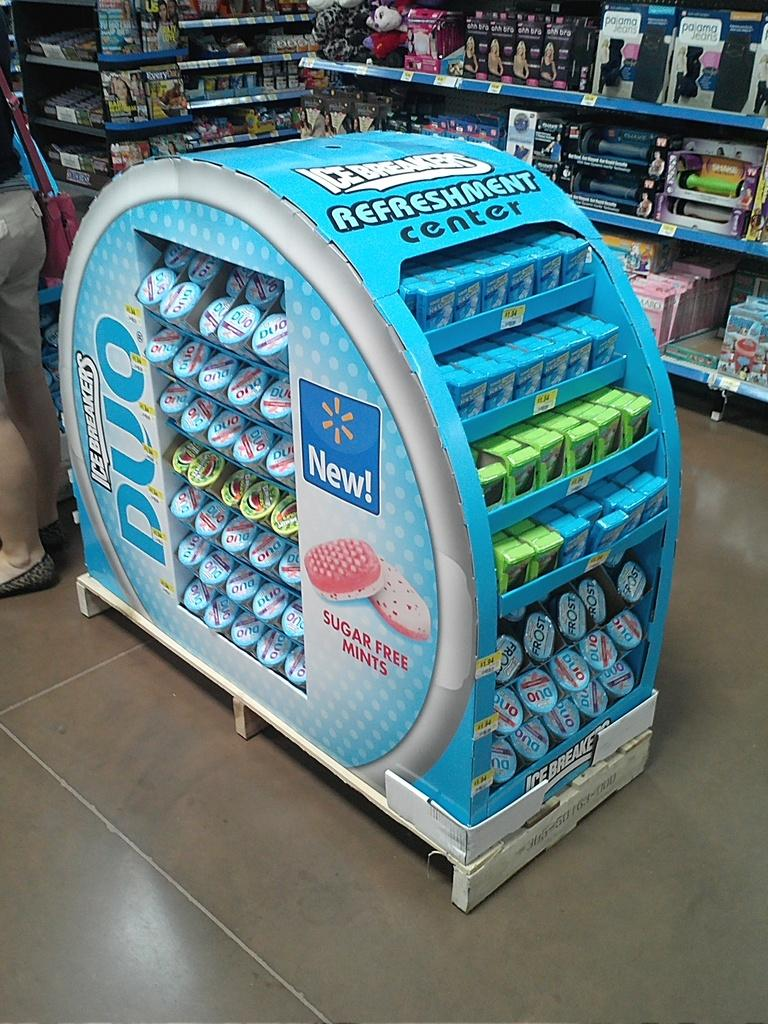<image>
Write a terse but informative summary of the picture. An Icebreakers gum display named Refreshment Center in a convenience store 